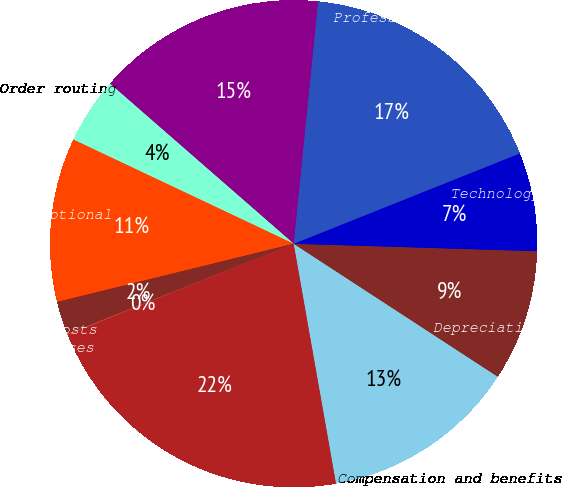<chart> <loc_0><loc_0><loc_500><loc_500><pie_chart><fcel>Compensation and benefits<fcel>Depreciation and amortization<fcel>Technology support services<fcel>Professional fees and outside<fcel>Royalty fees<fcel>Order routing<fcel>Travel and promotional<fcel>Facilities costs<fcel>Other expenses<fcel>Total operating expenses<nl><fcel>13.03%<fcel>8.7%<fcel>6.54%<fcel>17.35%<fcel>15.19%<fcel>4.38%<fcel>10.87%<fcel>2.21%<fcel>0.05%<fcel>21.68%<nl></chart> 